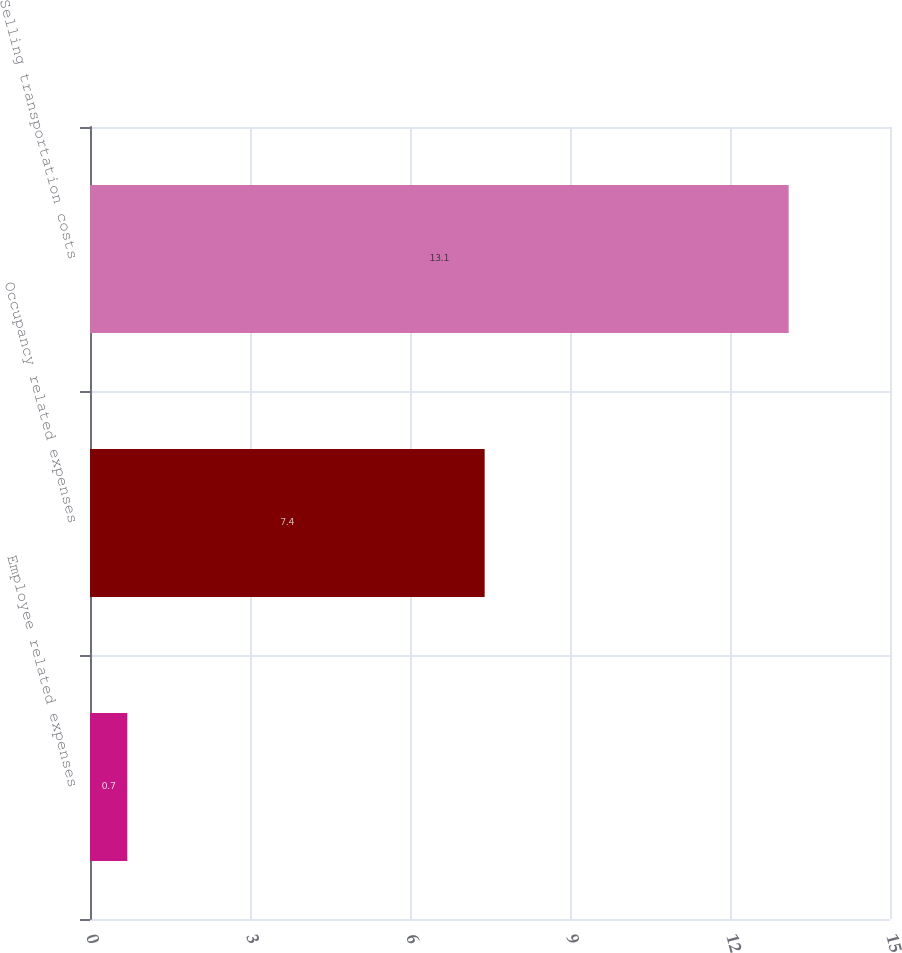<chart> <loc_0><loc_0><loc_500><loc_500><bar_chart><fcel>Employee related expenses<fcel>Occupancy related expenses<fcel>Selling transportation costs<nl><fcel>0.7<fcel>7.4<fcel>13.1<nl></chart> 